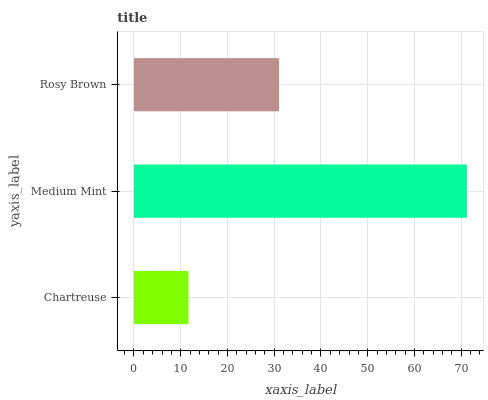Is Chartreuse the minimum?
Answer yes or no. Yes. Is Medium Mint the maximum?
Answer yes or no. Yes. Is Rosy Brown the minimum?
Answer yes or no. No. Is Rosy Brown the maximum?
Answer yes or no. No. Is Medium Mint greater than Rosy Brown?
Answer yes or no. Yes. Is Rosy Brown less than Medium Mint?
Answer yes or no. Yes. Is Rosy Brown greater than Medium Mint?
Answer yes or no. No. Is Medium Mint less than Rosy Brown?
Answer yes or no. No. Is Rosy Brown the high median?
Answer yes or no. Yes. Is Rosy Brown the low median?
Answer yes or no. Yes. Is Medium Mint the high median?
Answer yes or no. No. Is Medium Mint the low median?
Answer yes or no. No. 